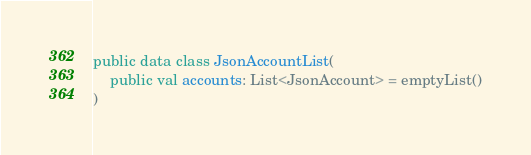<code> <loc_0><loc_0><loc_500><loc_500><_Kotlin_>public data class JsonAccountList(
    public val accounts: List<JsonAccount> = emptyList()
)
</code> 